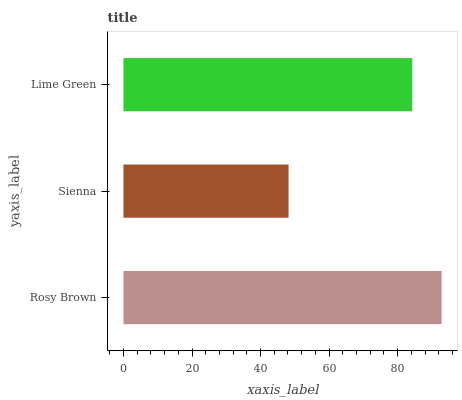Is Sienna the minimum?
Answer yes or no. Yes. Is Rosy Brown the maximum?
Answer yes or no. Yes. Is Lime Green the minimum?
Answer yes or no. No. Is Lime Green the maximum?
Answer yes or no. No. Is Lime Green greater than Sienna?
Answer yes or no. Yes. Is Sienna less than Lime Green?
Answer yes or no. Yes. Is Sienna greater than Lime Green?
Answer yes or no. No. Is Lime Green less than Sienna?
Answer yes or no. No. Is Lime Green the high median?
Answer yes or no. Yes. Is Lime Green the low median?
Answer yes or no. Yes. Is Sienna the high median?
Answer yes or no. No. Is Sienna the low median?
Answer yes or no. No. 